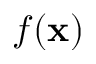<formula> <loc_0><loc_0><loc_500><loc_500>f ( x )</formula> 